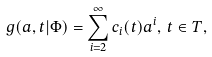<formula> <loc_0><loc_0><loc_500><loc_500>g ( a , t | \Phi ) = \sum _ { i = 2 } ^ { \infty } c _ { i } ( t ) a ^ { i } , \, t \in T ,</formula> 